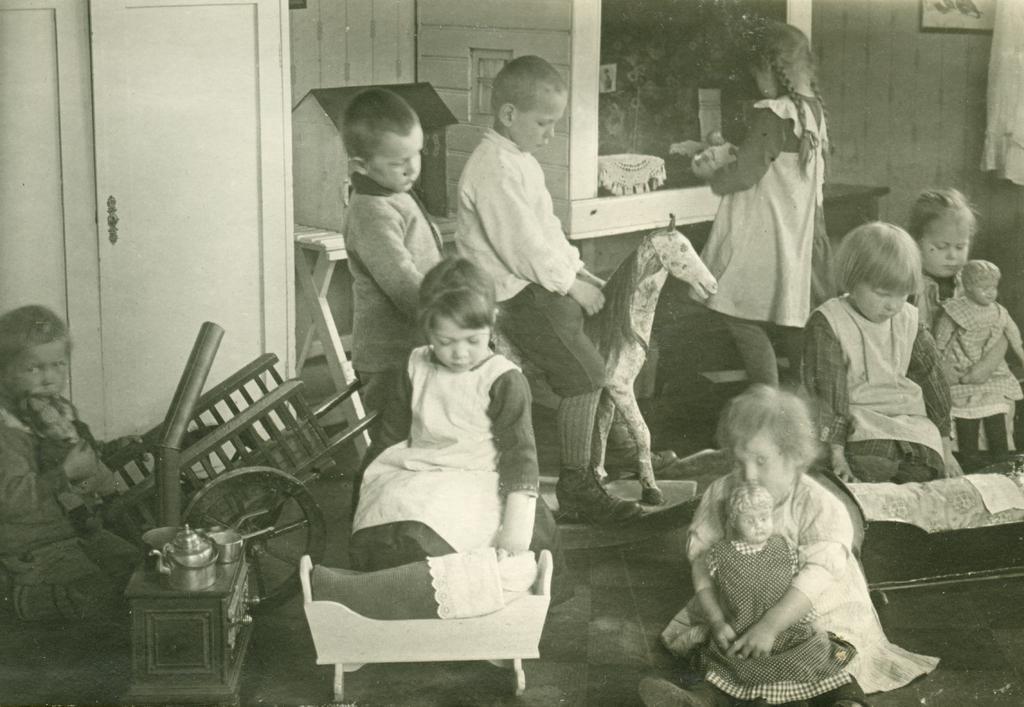Please provide a concise description of this image. In this image, we can see some kids playing with different objects, we can see a door and there is a wall on the right side. 